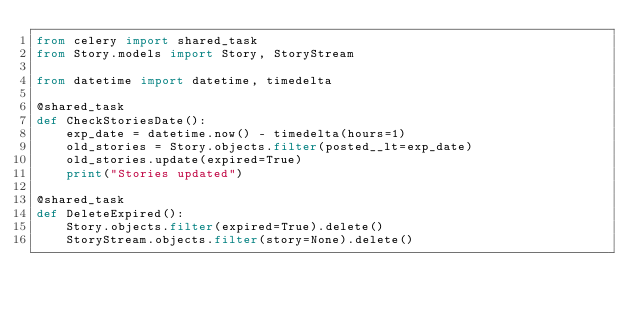Convert code to text. <code><loc_0><loc_0><loc_500><loc_500><_Python_>from celery import shared_task
from Story.models import Story, StoryStream

from datetime import datetime, timedelta

@shared_task
def CheckStoriesDate():
	exp_date = datetime.now() - timedelta(hours=1)
	old_stories = Story.objects.filter(posted__lt=exp_date)
	old_stories.update(expired=True)
	print("Stories updated")

@shared_task
def DeleteExpired():
	Story.objects.filter(expired=True).delete()
	StoryStream.objects.filter(story=None).delete()</code> 